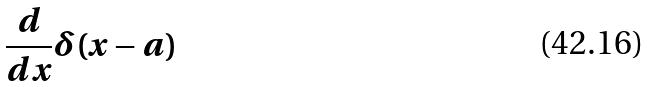<formula> <loc_0><loc_0><loc_500><loc_500>\frac { d } { d x } \delta ( x - a )</formula> 